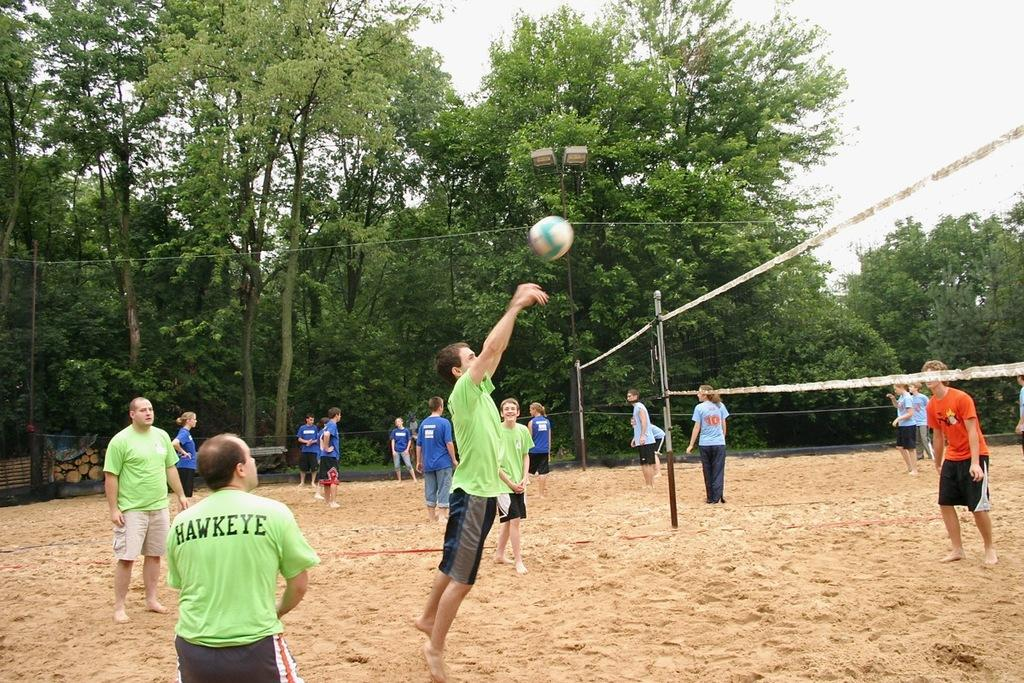<image>
Render a clear and concise summary of the photo. a person with a Hawkeye shirt is playing some volleyball 